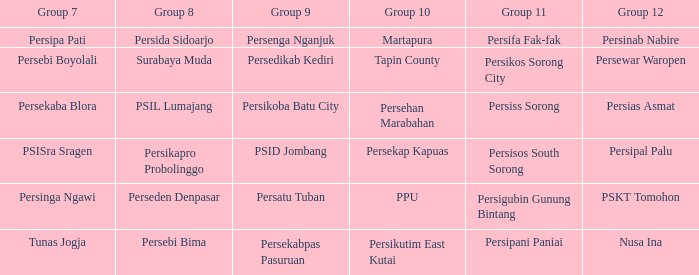Who played in group 12 when persikutim east kutai played in group 10? Nusa Ina. 